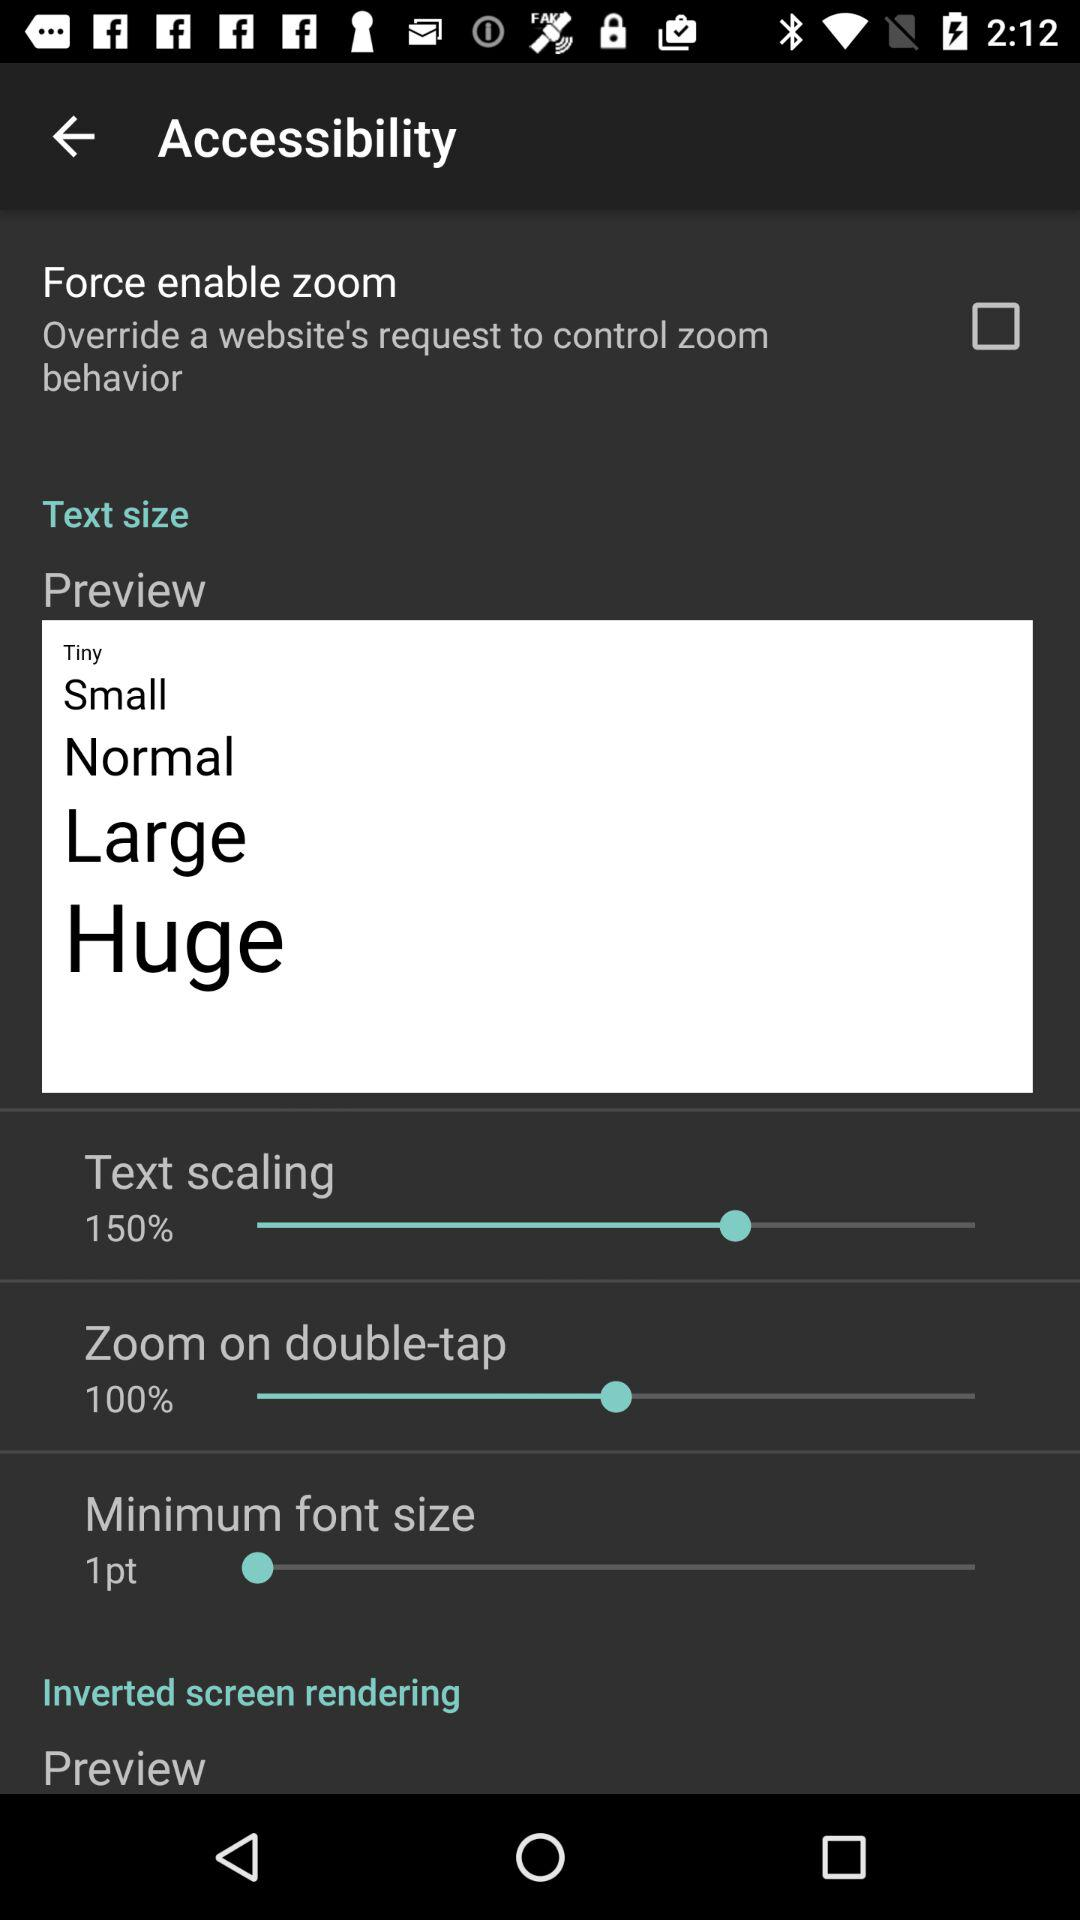What is the selected minimum font size? The selected minimum font size is 1 point. 